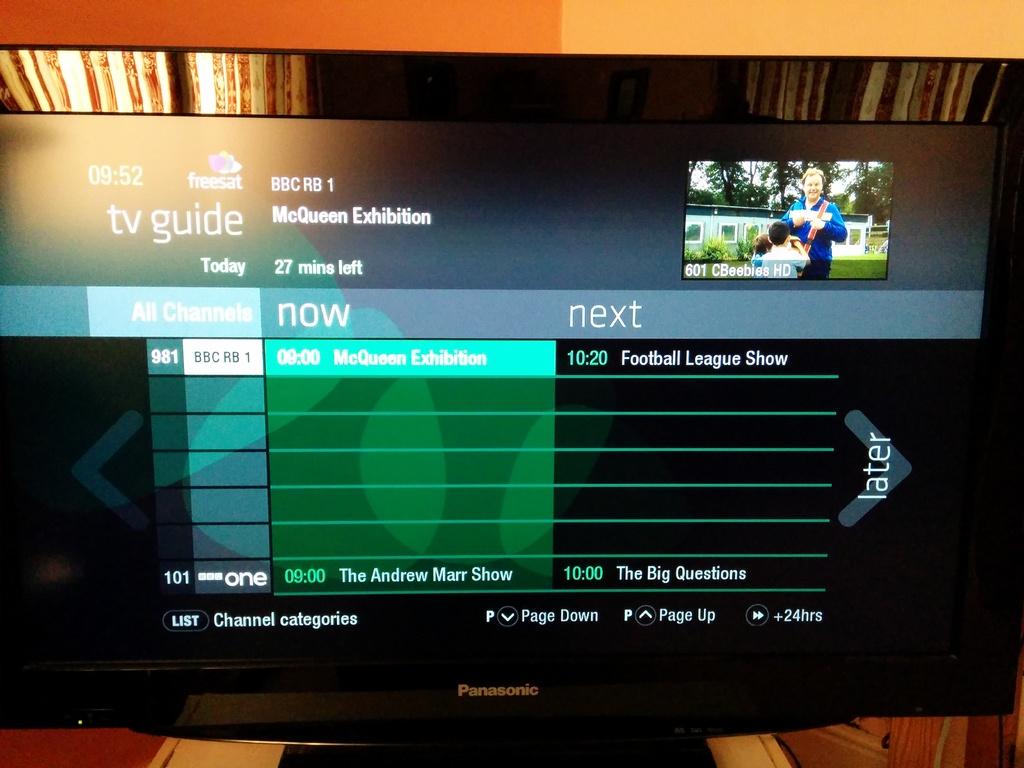How many minutes left on the mcqueen exhibition?
Your response must be concise. 27. 